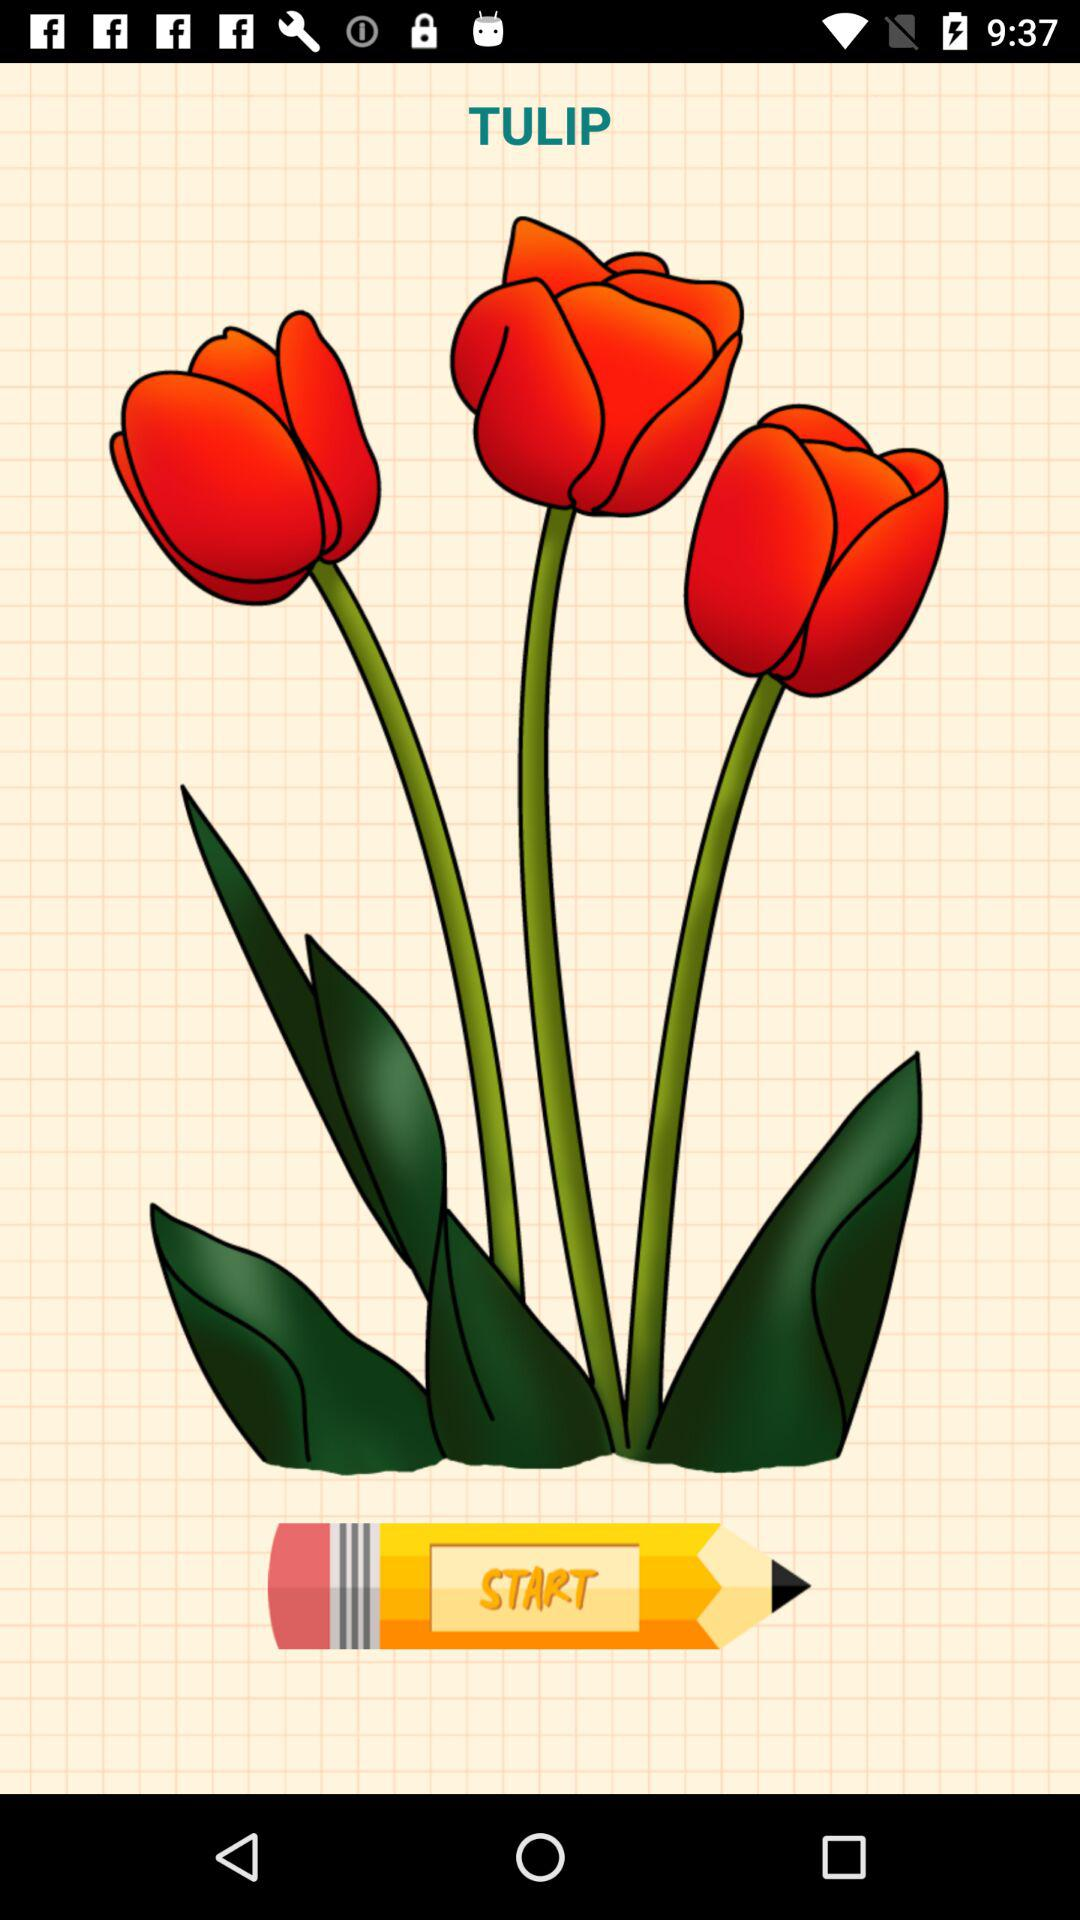What is the flower name? The flower name is Tulip. 